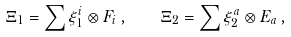<formula> <loc_0><loc_0><loc_500><loc_500>\Xi _ { 1 } = \sum \xi _ { 1 } ^ { i } \otimes F _ { i } \, , \quad \Xi _ { 2 } = \sum \xi _ { 2 } ^ { a } \otimes E _ { a } \, ,</formula> 